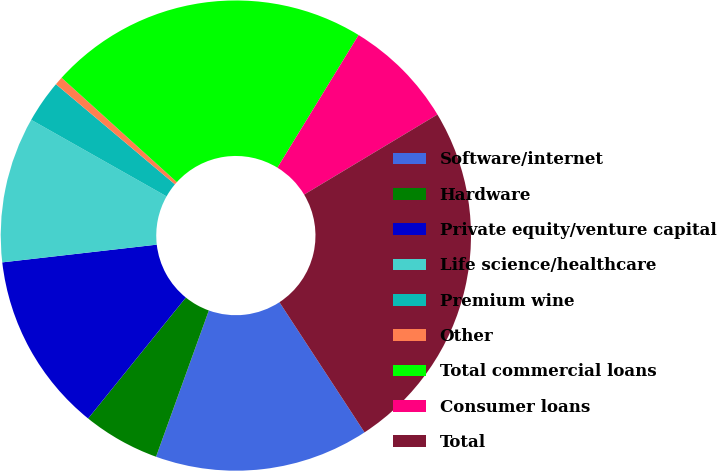Convert chart. <chart><loc_0><loc_0><loc_500><loc_500><pie_chart><fcel>Software/internet<fcel>Hardware<fcel>Private equity/venture capital<fcel>Life science/healthcare<fcel>Premium wine<fcel>Other<fcel>Total commercial loans<fcel>Consumer loans<fcel>Total<nl><fcel>14.73%<fcel>5.3%<fcel>12.37%<fcel>10.01%<fcel>2.94%<fcel>0.58%<fcel>22.03%<fcel>7.65%<fcel>24.39%<nl></chart> 